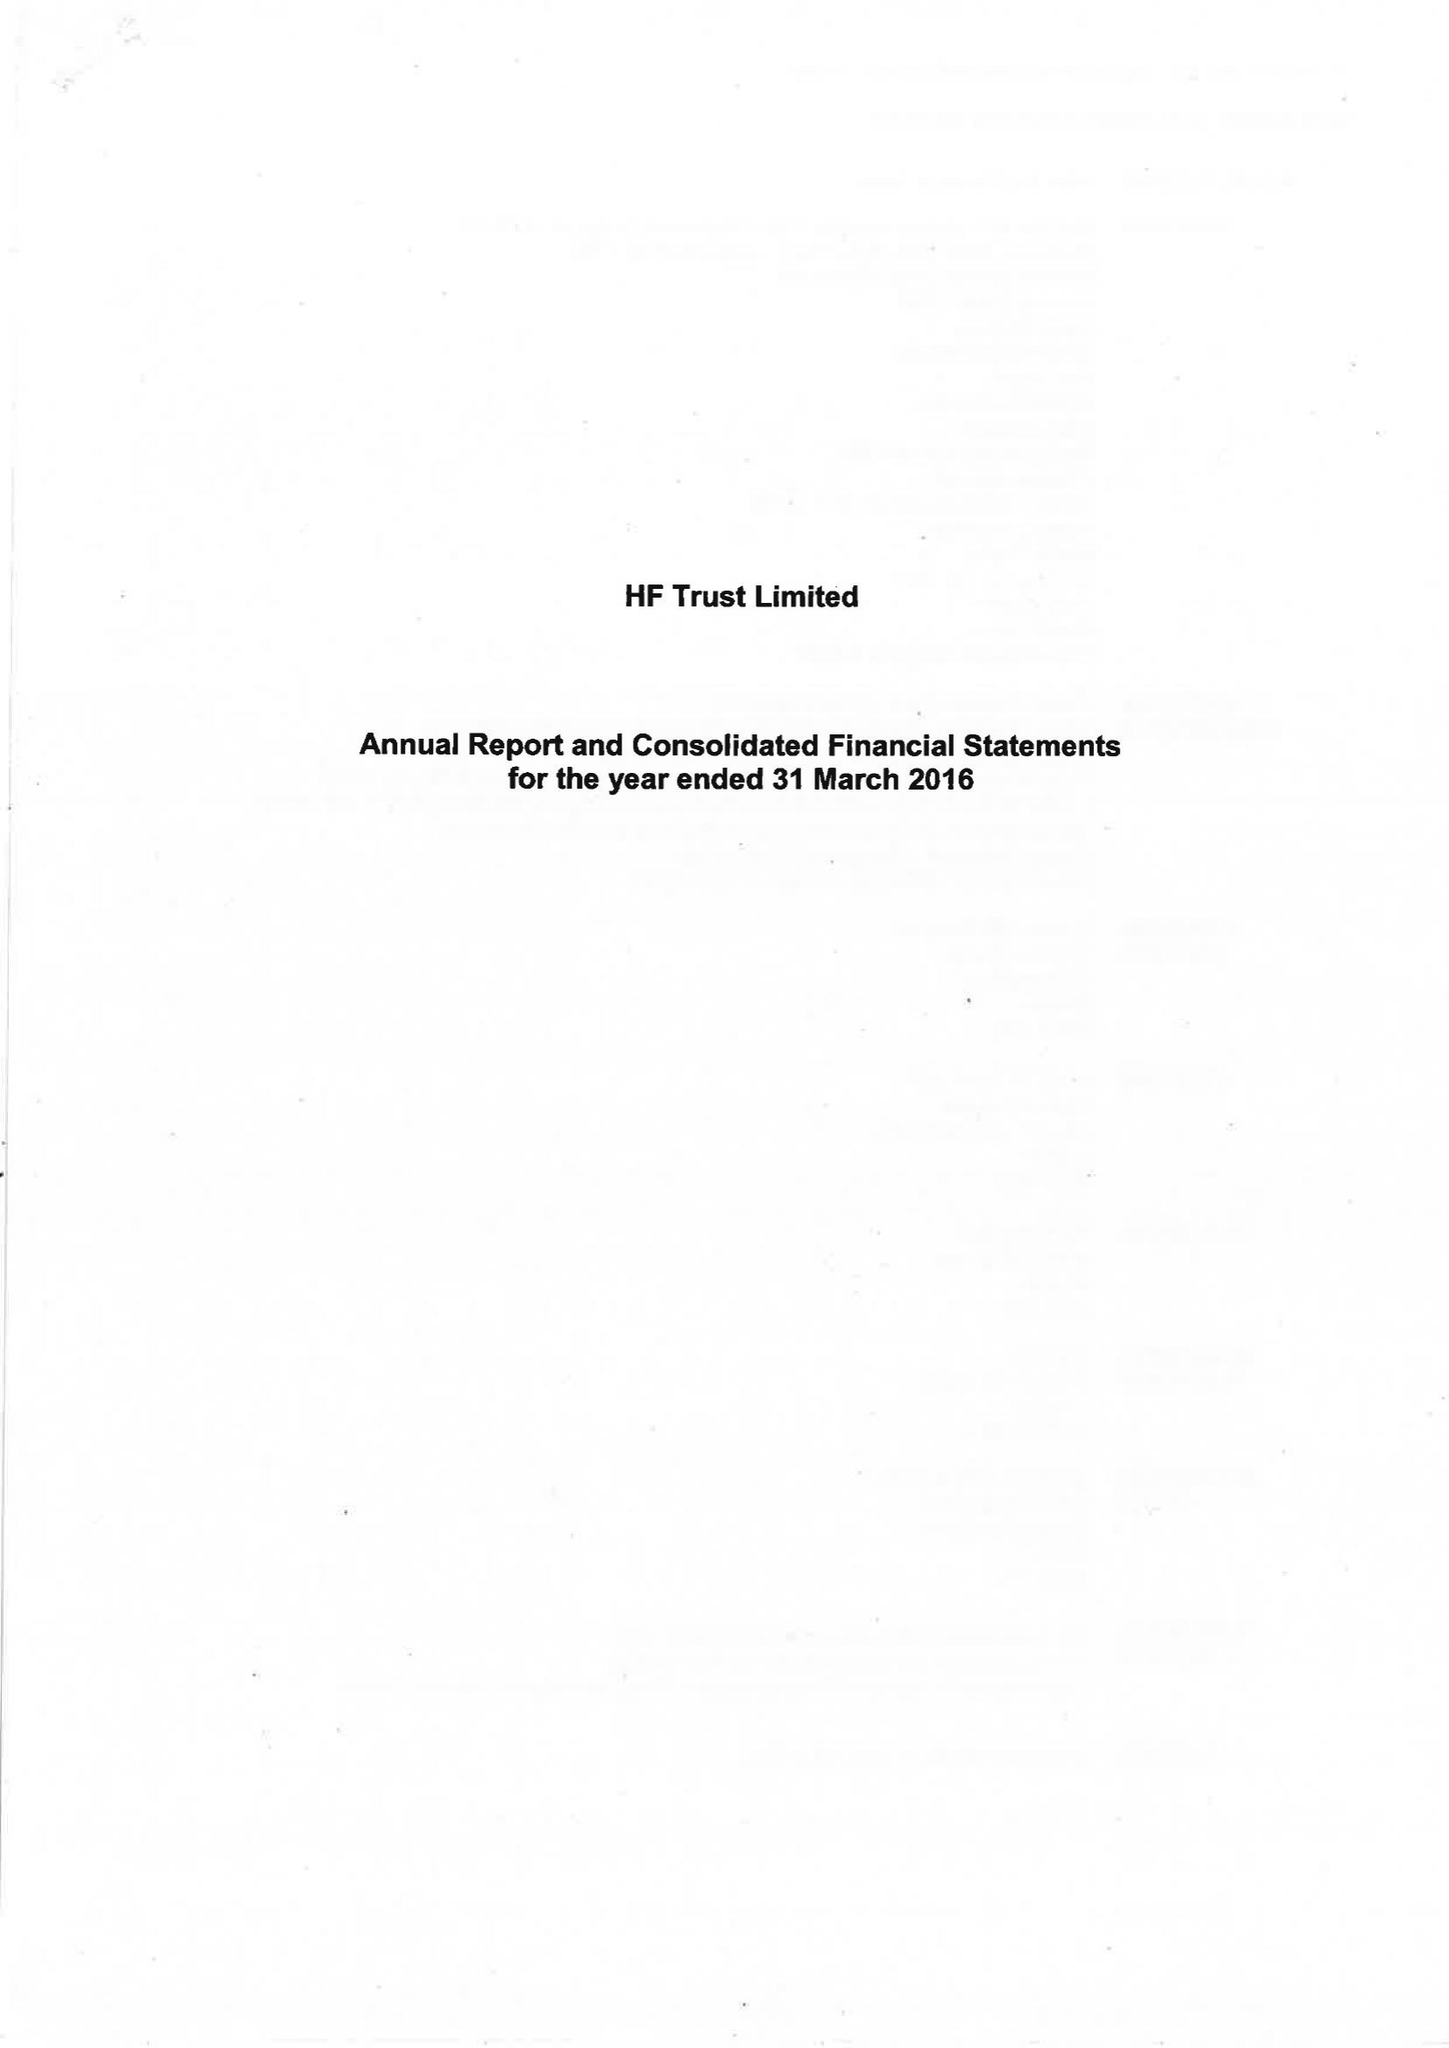What is the value for the charity_name?
Answer the question using a single word or phrase. Hf Trust Ltd. 